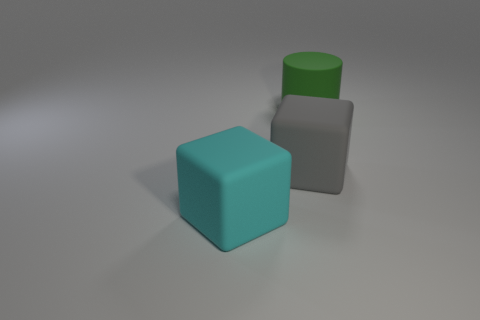How many things are either big green matte cylinders or large matte blocks behind the cyan rubber block?
Offer a very short reply. 2. There is a object that is behind the gray rubber object; is its size the same as the large gray rubber block?
Provide a succinct answer. Yes. What number of other objects are the same shape as the green rubber thing?
Keep it short and to the point. 0. How many red objects are cylinders or rubber cubes?
Your answer should be very brief. 0. Does the large matte block that is behind the big cyan block have the same color as the big rubber cylinder?
Your response must be concise. No. There is a gray thing that is the same material as the large cyan thing; what shape is it?
Keep it short and to the point. Cube. There is a big thing that is both behind the cyan object and in front of the green matte object; what color is it?
Your response must be concise. Gray. How big is the cube to the right of the big matte thing in front of the gray rubber cube?
Offer a terse response. Large. Is there a big cube that has the same color as the large cylinder?
Ensure brevity in your answer.  No. Are there an equal number of big green things that are in front of the large rubber cylinder and rubber cubes?
Give a very brief answer. No. 